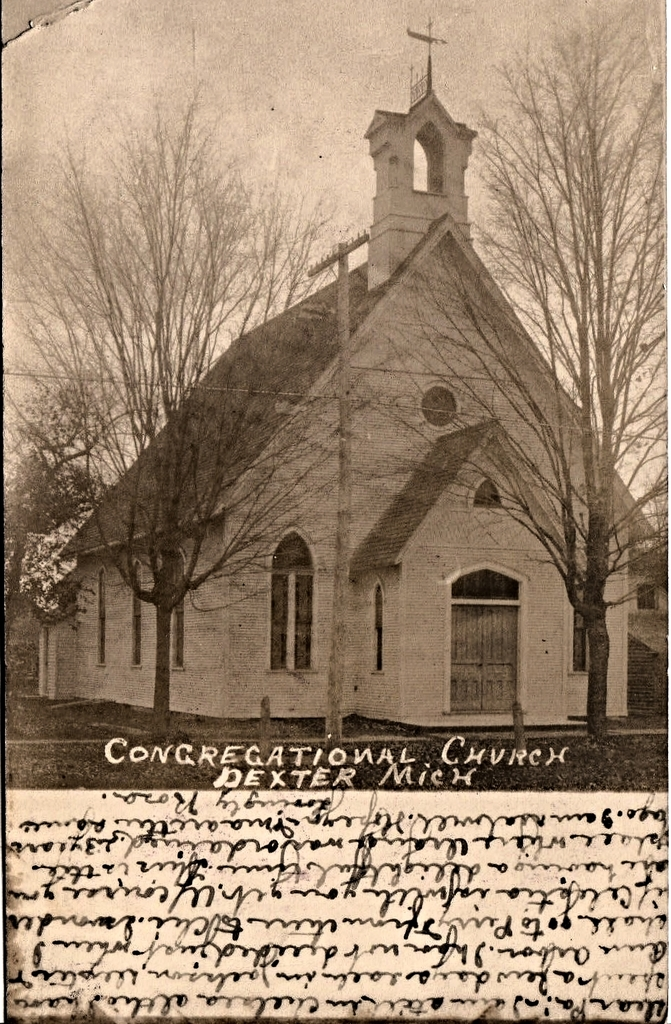Can you describe the architectural features visible in this image of the church? The church features a traditional Gothic Revival design, evidenced by its pointed arch windows, a steeply pitched roof, and a prominent steeple with a bell tower, all typical of the style aimed to inspire spiritual awe and grandeur. 